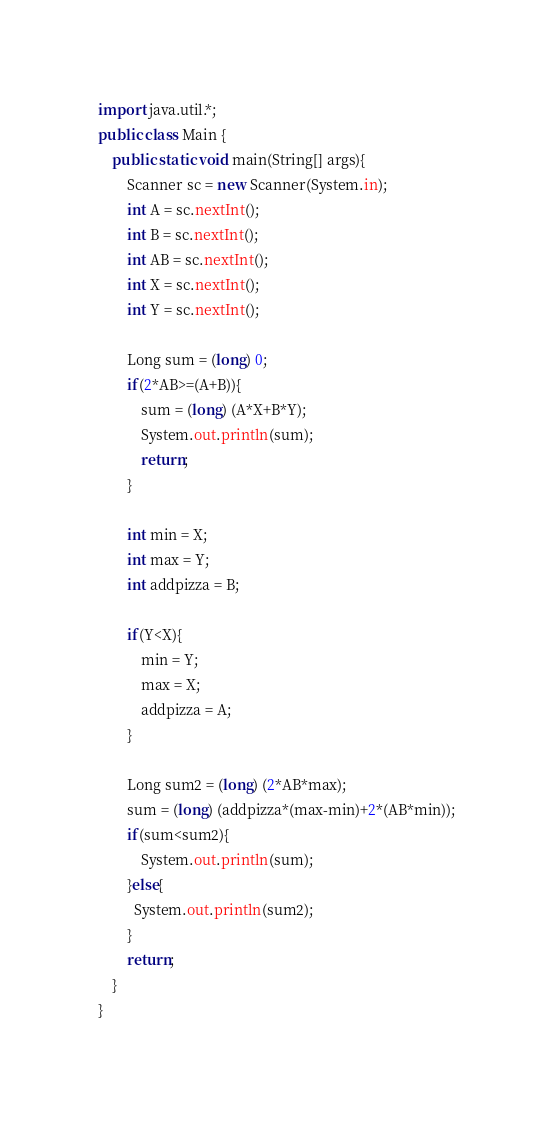Convert code to text. <code><loc_0><loc_0><loc_500><loc_500><_Java_>import java.util.*;
public class Main {
	public static void main(String[] args){
		Scanner sc = new Scanner(System.in);
      	int A = sc.nextInt();
      	int B = sc.nextInt();
     	int AB = sc.nextInt();
		int X = sc.nextInt();
      	int Y = sc.nextInt();
      	
        Long sum = (long) 0;
      	if(2*AB>=(A+B)){
          	sum = (long) (A*X+B*Y);
      		System.out.println(sum);
          	return;
        }
      
      	int min = X;
      	int max = Y;
      	int addpizza = B; 
      	
      	if(Y<X){
        	min = Y;
          	max = X;
          	addpizza = A; 
        }
      
        Long sum2 = (long) (2*AB*max);
      	sum = (long) (addpizza*(max-min)+2*(AB*min));
      	if(sum<sum2){
      		System.out.println(sum);
        }else{
          System.out.println(sum2);
        }
        return;
	}
}
</code> 